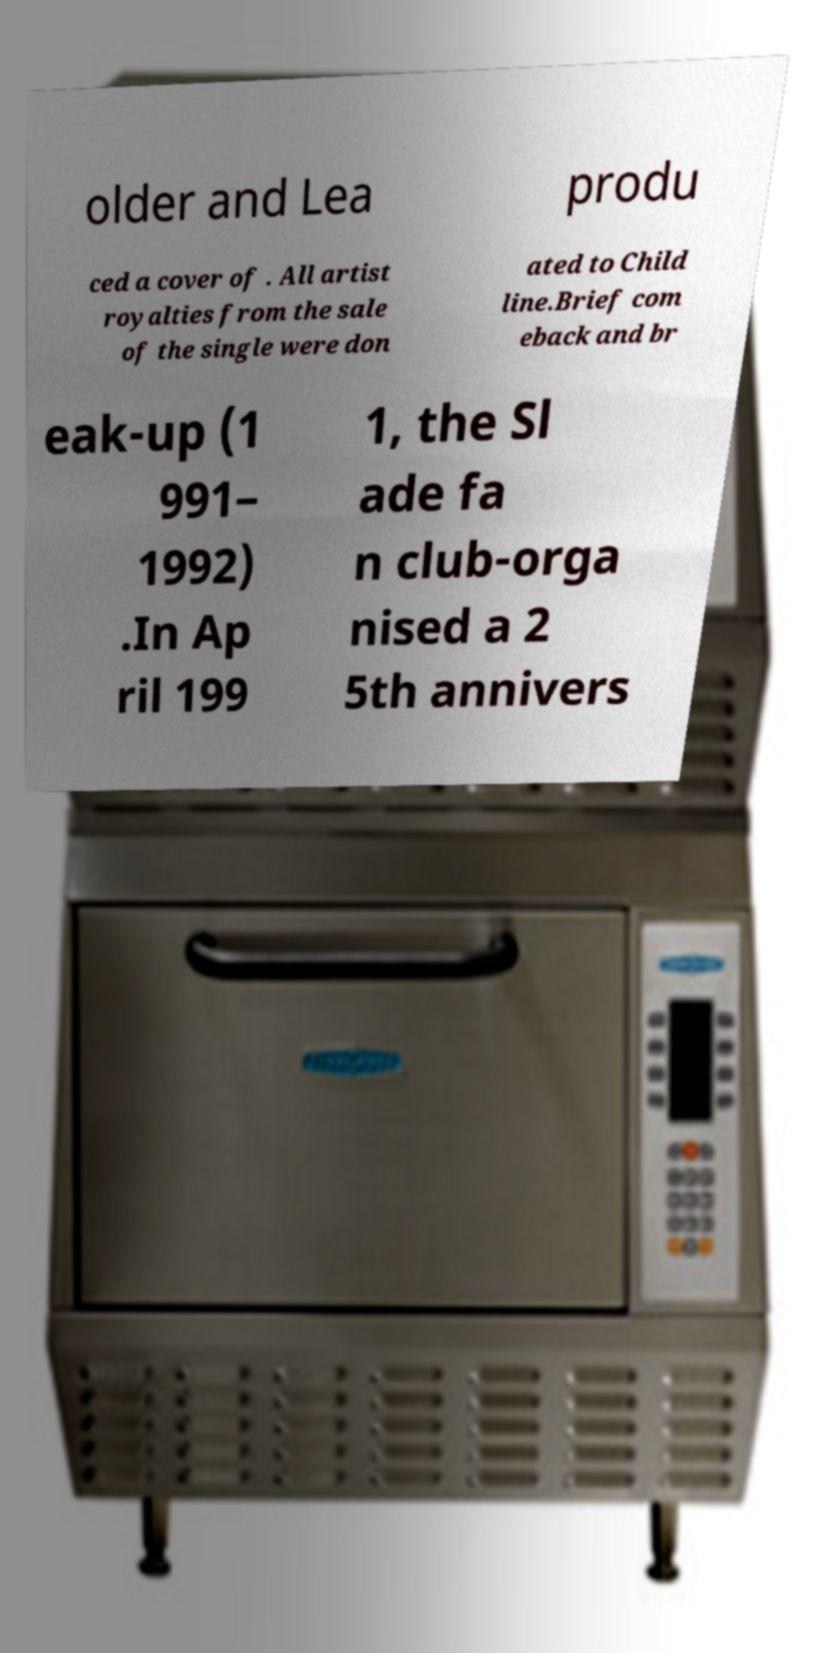I need the written content from this picture converted into text. Can you do that? older and Lea produ ced a cover of . All artist royalties from the sale of the single were don ated to Child line.Brief com eback and br eak-up (1 991– 1992) .In Ap ril 199 1, the Sl ade fa n club-orga nised a 2 5th annivers 